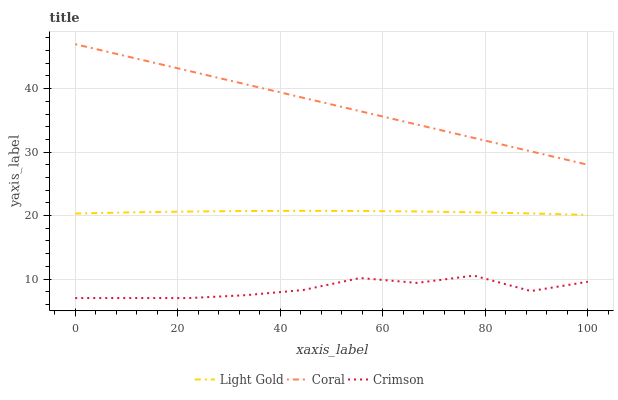Does Light Gold have the minimum area under the curve?
Answer yes or no. No. Does Light Gold have the maximum area under the curve?
Answer yes or no. No. Is Light Gold the smoothest?
Answer yes or no. No. Is Light Gold the roughest?
Answer yes or no. No. Does Light Gold have the lowest value?
Answer yes or no. No. Does Light Gold have the highest value?
Answer yes or no. No. Is Crimson less than Light Gold?
Answer yes or no. Yes. Is Light Gold greater than Crimson?
Answer yes or no. Yes. Does Crimson intersect Light Gold?
Answer yes or no. No. 